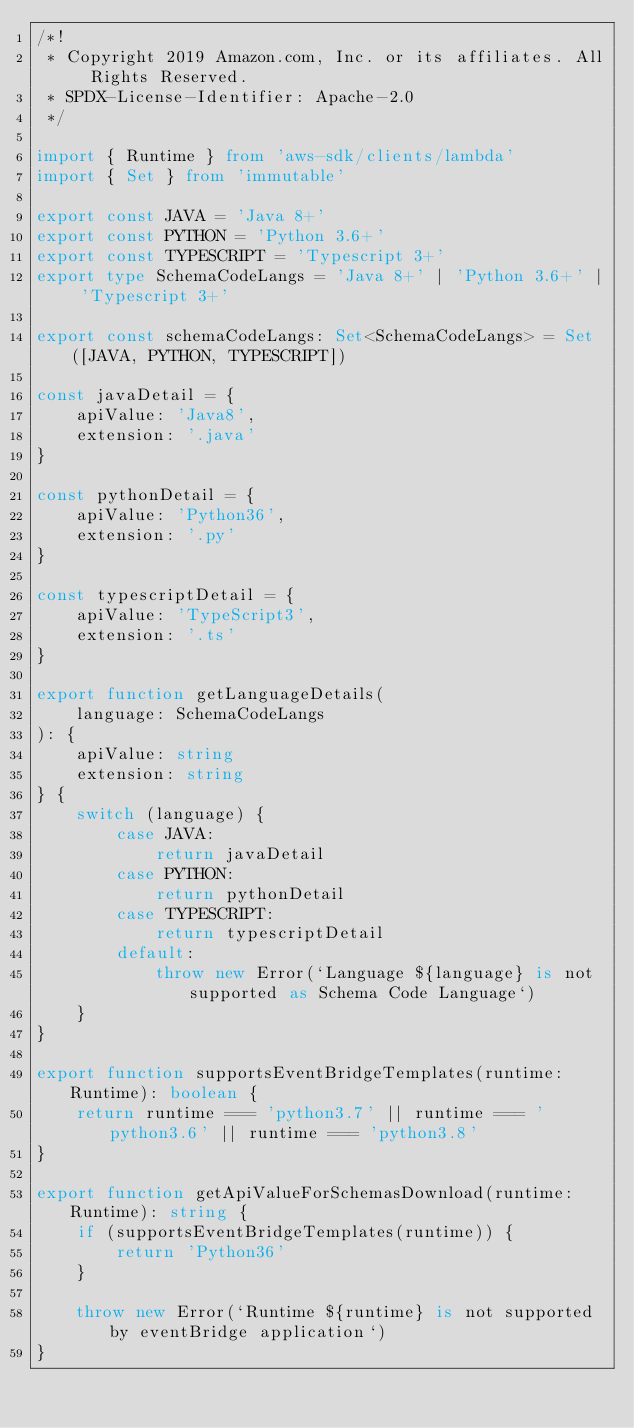Convert code to text. <code><loc_0><loc_0><loc_500><loc_500><_TypeScript_>/*!
 * Copyright 2019 Amazon.com, Inc. or its affiliates. All Rights Reserved.
 * SPDX-License-Identifier: Apache-2.0
 */

import { Runtime } from 'aws-sdk/clients/lambda'
import { Set } from 'immutable'

export const JAVA = 'Java 8+'
export const PYTHON = 'Python 3.6+'
export const TYPESCRIPT = 'Typescript 3+'
export type SchemaCodeLangs = 'Java 8+' | 'Python 3.6+' | 'Typescript 3+'

export const schemaCodeLangs: Set<SchemaCodeLangs> = Set([JAVA, PYTHON, TYPESCRIPT])

const javaDetail = {
    apiValue: 'Java8',
    extension: '.java'
}

const pythonDetail = {
    apiValue: 'Python36',
    extension: '.py'
}

const typescriptDetail = {
    apiValue: 'TypeScript3',
    extension: '.ts'
}

export function getLanguageDetails(
    language: SchemaCodeLangs
): {
    apiValue: string
    extension: string
} {
    switch (language) {
        case JAVA:
            return javaDetail
        case PYTHON:
            return pythonDetail
        case TYPESCRIPT:
            return typescriptDetail
        default:
            throw new Error(`Language ${language} is not supported as Schema Code Language`)
    }
}

export function supportsEventBridgeTemplates(runtime: Runtime): boolean {
    return runtime === 'python3.7' || runtime === 'python3.6' || runtime === 'python3.8'
}

export function getApiValueForSchemasDownload(runtime: Runtime): string {
    if (supportsEventBridgeTemplates(runtime)) {
        return 'Python36'
    }

    throw new Error(`Runtime ${runtime} is not supported by eventBridge application`)
}
</code> 